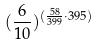Convert formula to latex. <formula><loc_0><loc_0><loc_500><loc_500>( \frac { 6 } { 1 0 } ) ^ { ( \frac { 5 8 } { 3 9 9 } \cdot 3 9 5 ) }</formula> 